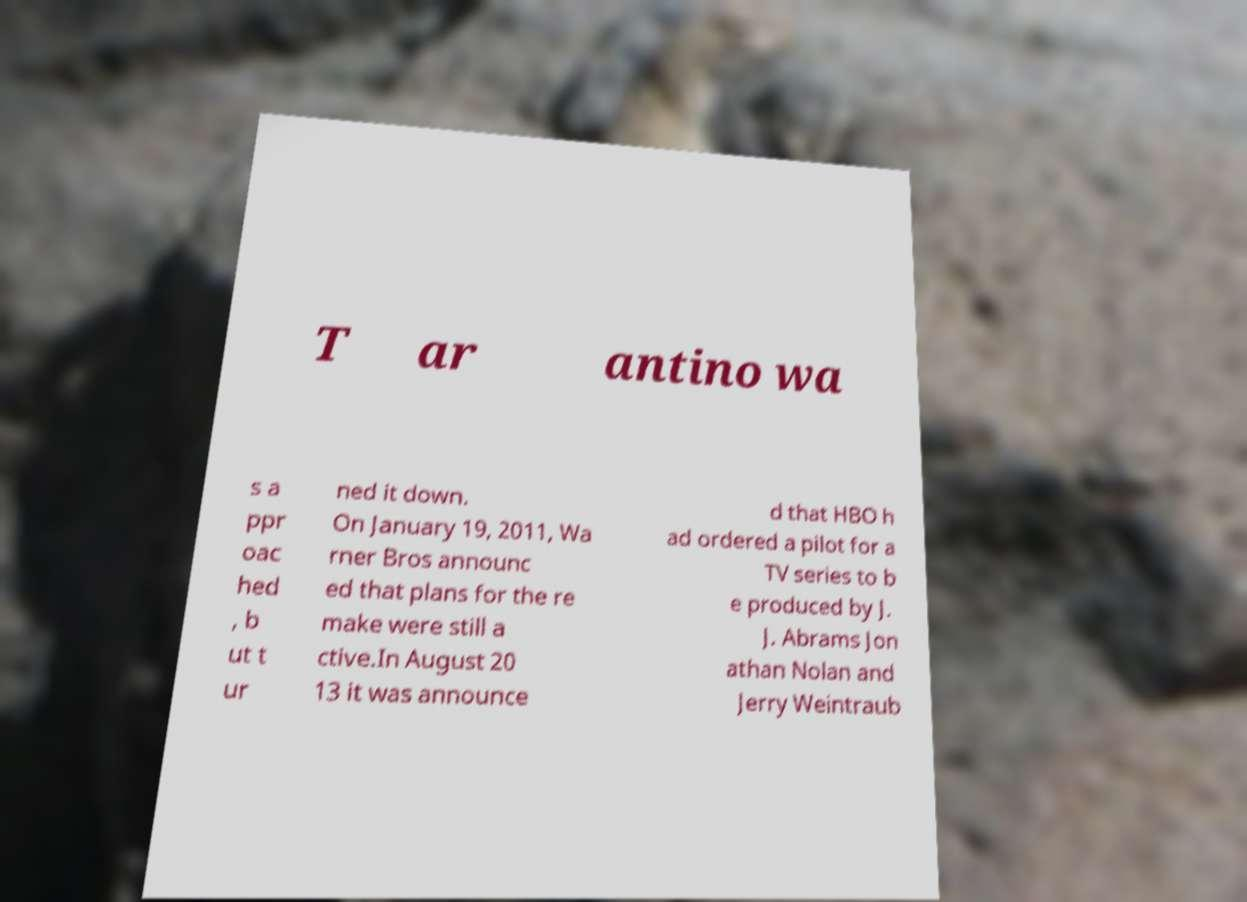What messages or text are displayed in this image? I need them in a readable, typed format. T ar antino wa s a ppr oac hed , b ut t ur ned it down. On January 19, 2011, Wa rner Bros announc ed that plans for the re make were still a ctive.In August 20 13 it was announce d that HBO h ad ordered a pilot for a TV series to b e produced by J. J. Abrams Jon athan Nolan and Jerry Weintraub 